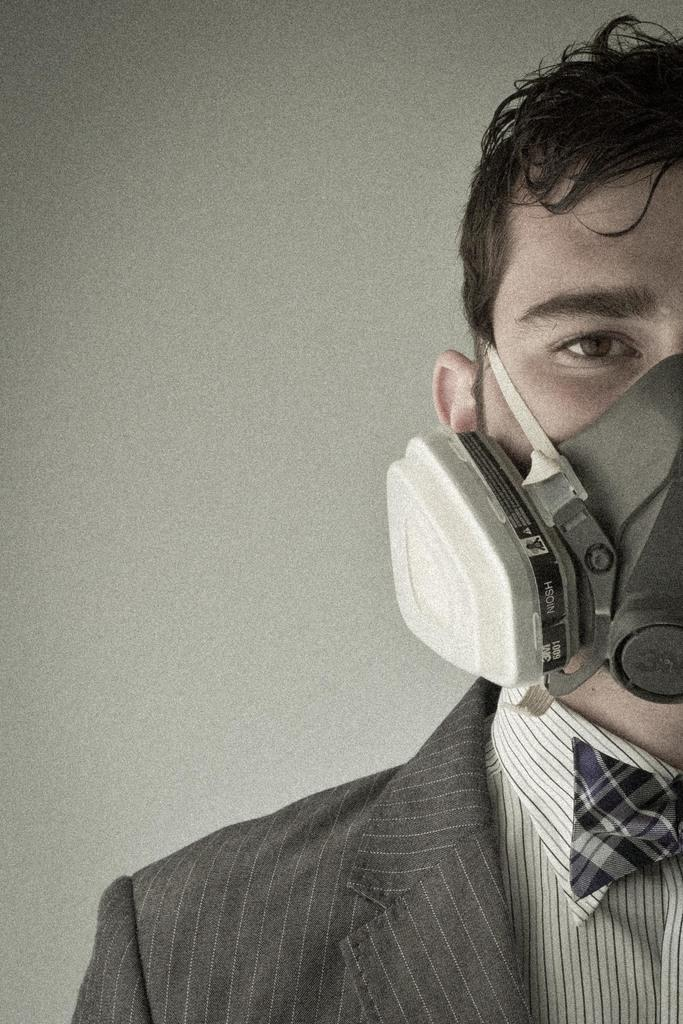What is present in the image? There is a person in the image. Can you describe the person's appearance? The person is wearing a mask on their face. What can be seen in the background of the image? There is a wall visible in the background of the image. What type of snake can be seen slithering on the wall in the image? There is no snake present in the image; the wall is visible in the background, but no snake is mentioned in the facts. 